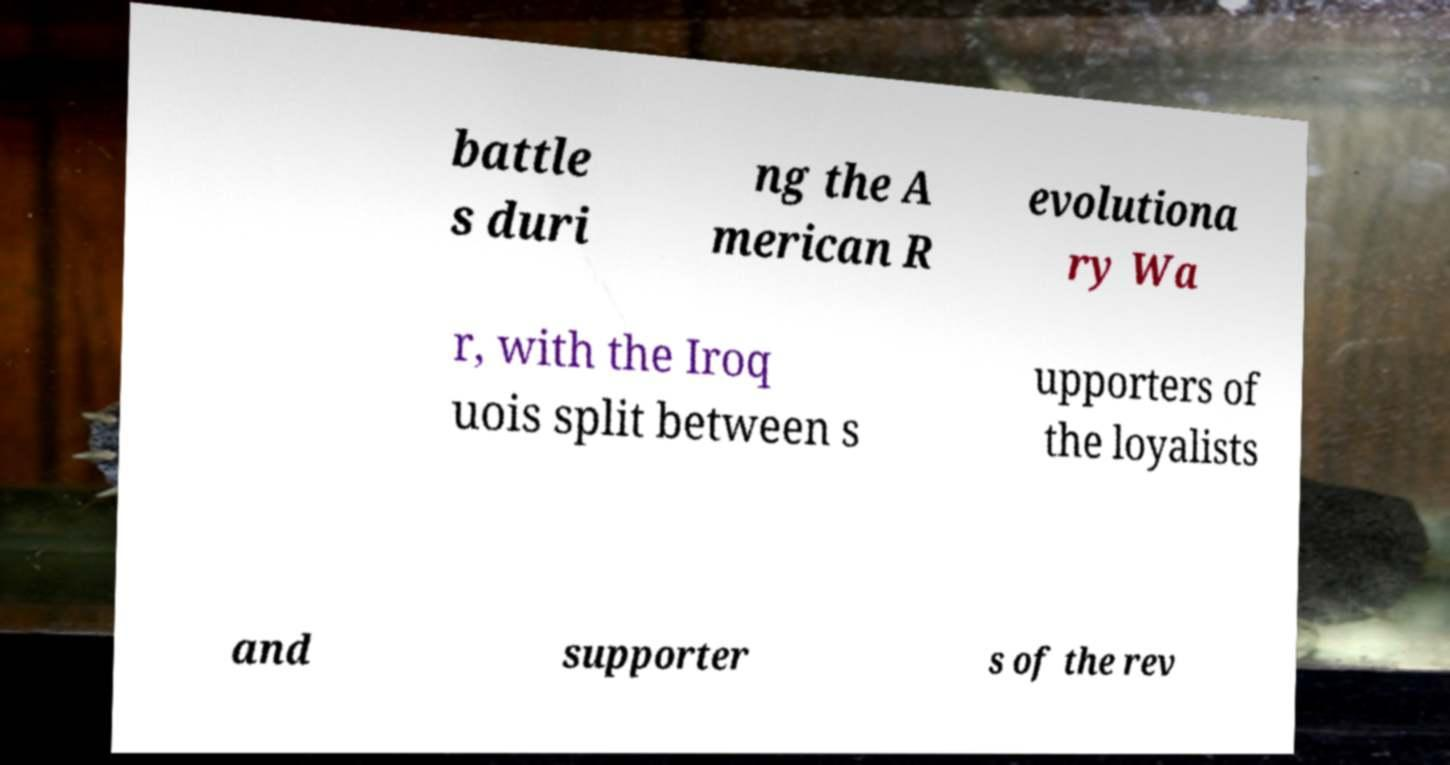For documentation purposes, I need the text within this image transcribed. Could you provide that? battle s duri ng the A merican R evolutiona ry Wa r, with the Iroq uois split between s upporters of the loyalists and supporter s of the rev 